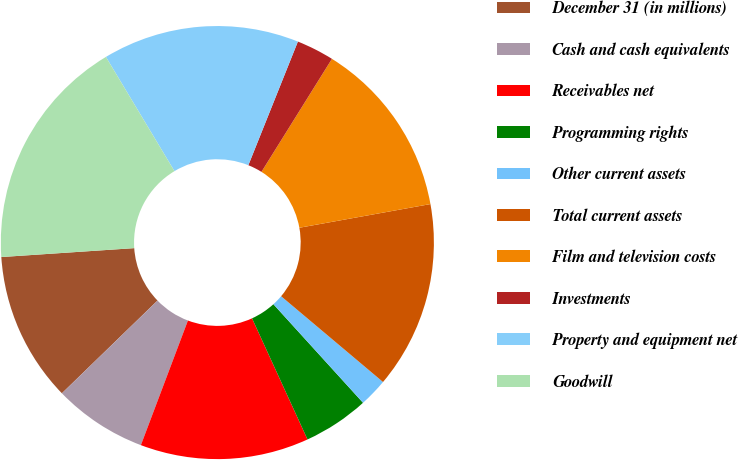Convert chart to OTSL. <chart><loc_0><loc_0><loc_500><loc_500><pie_chart><fcel>December 31 (in millions)<fcel>Cash and cash equivalents<fcel>Receivables net<fcel>Programming rights<fcel>Other current assets<fcel>Total current assets<fcel>Film and television costs<fcel>Investments<fcel>Property and equipment net<fcel>Goodwill<nl><fcel>11.19%<fcel>7.0%<fcel>12.58%<fcel>4.91%<fcel>2.12%<fcel>13.98%<fcel>13.28%<fcel>2.81%<fcel>14.67%<fcel>17.46%<nl></chart> 